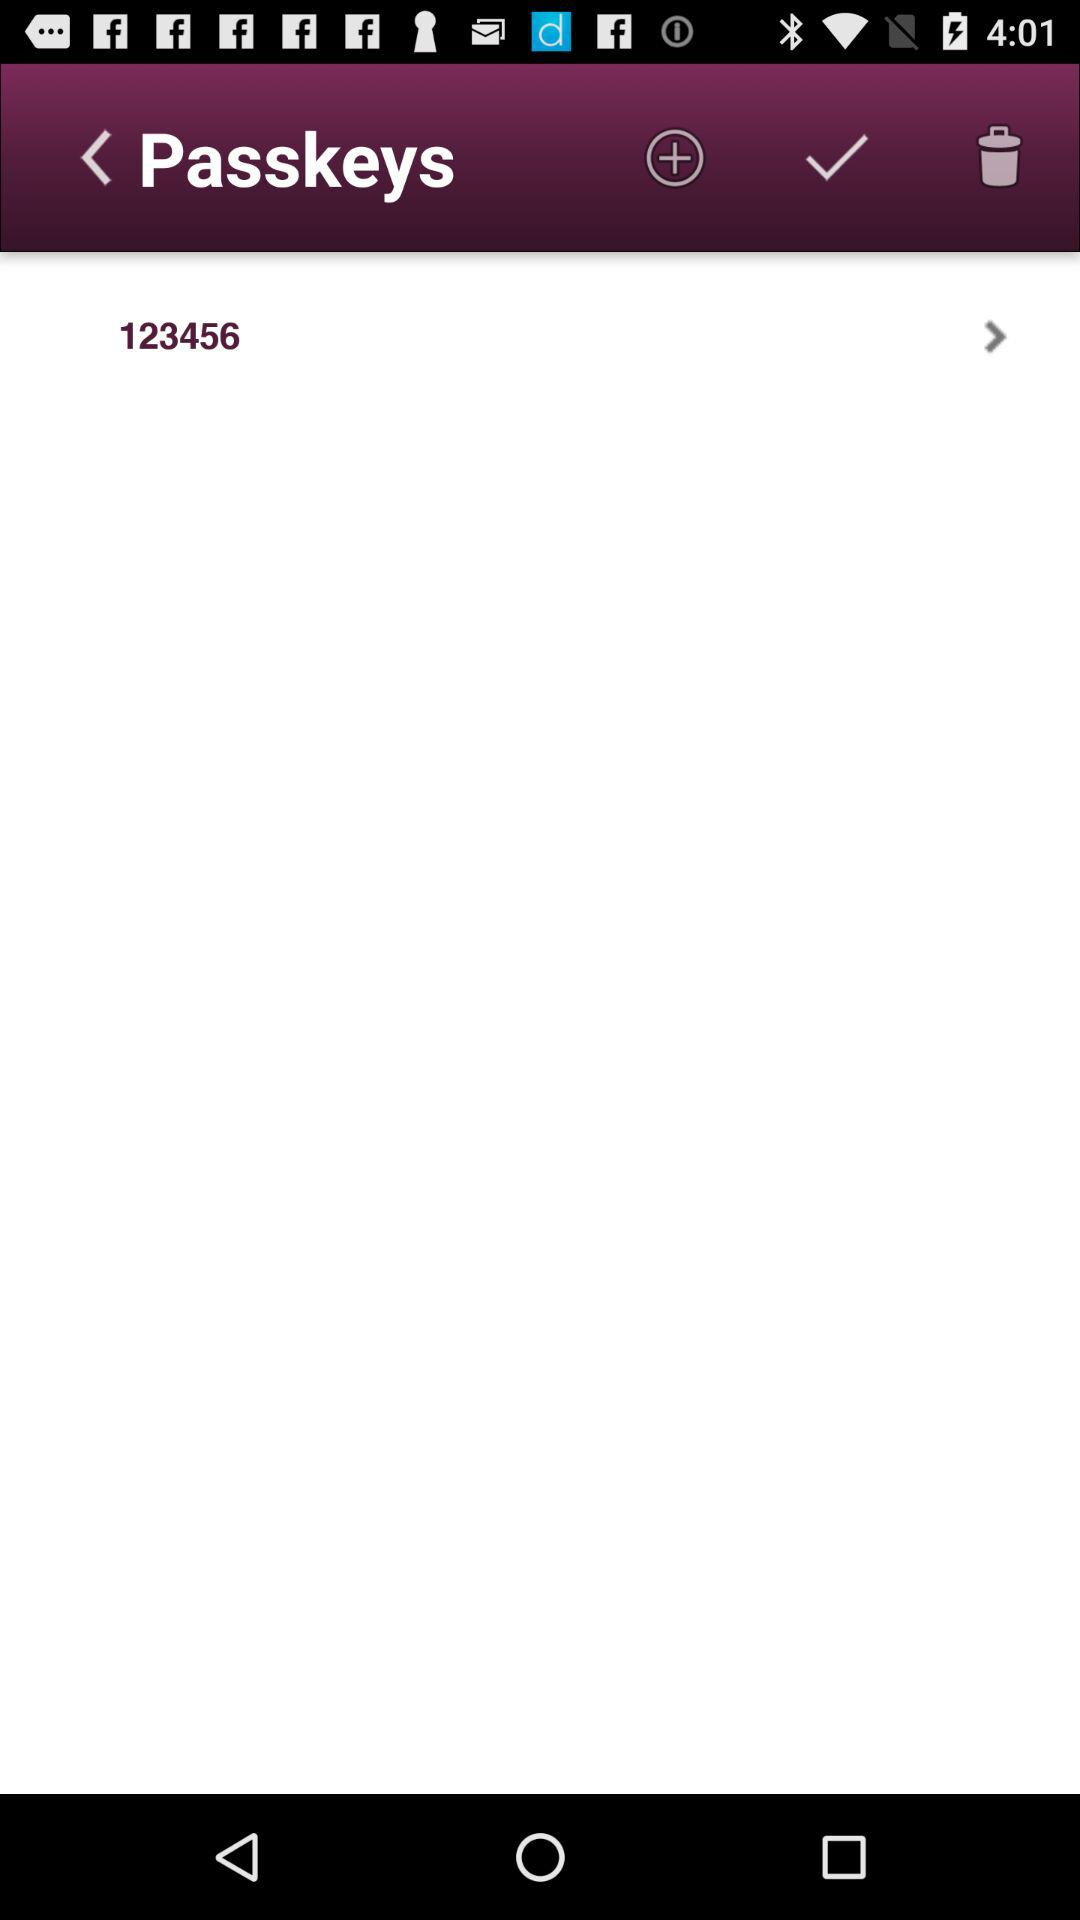What is the given passkey? The given passkey is "123456". 